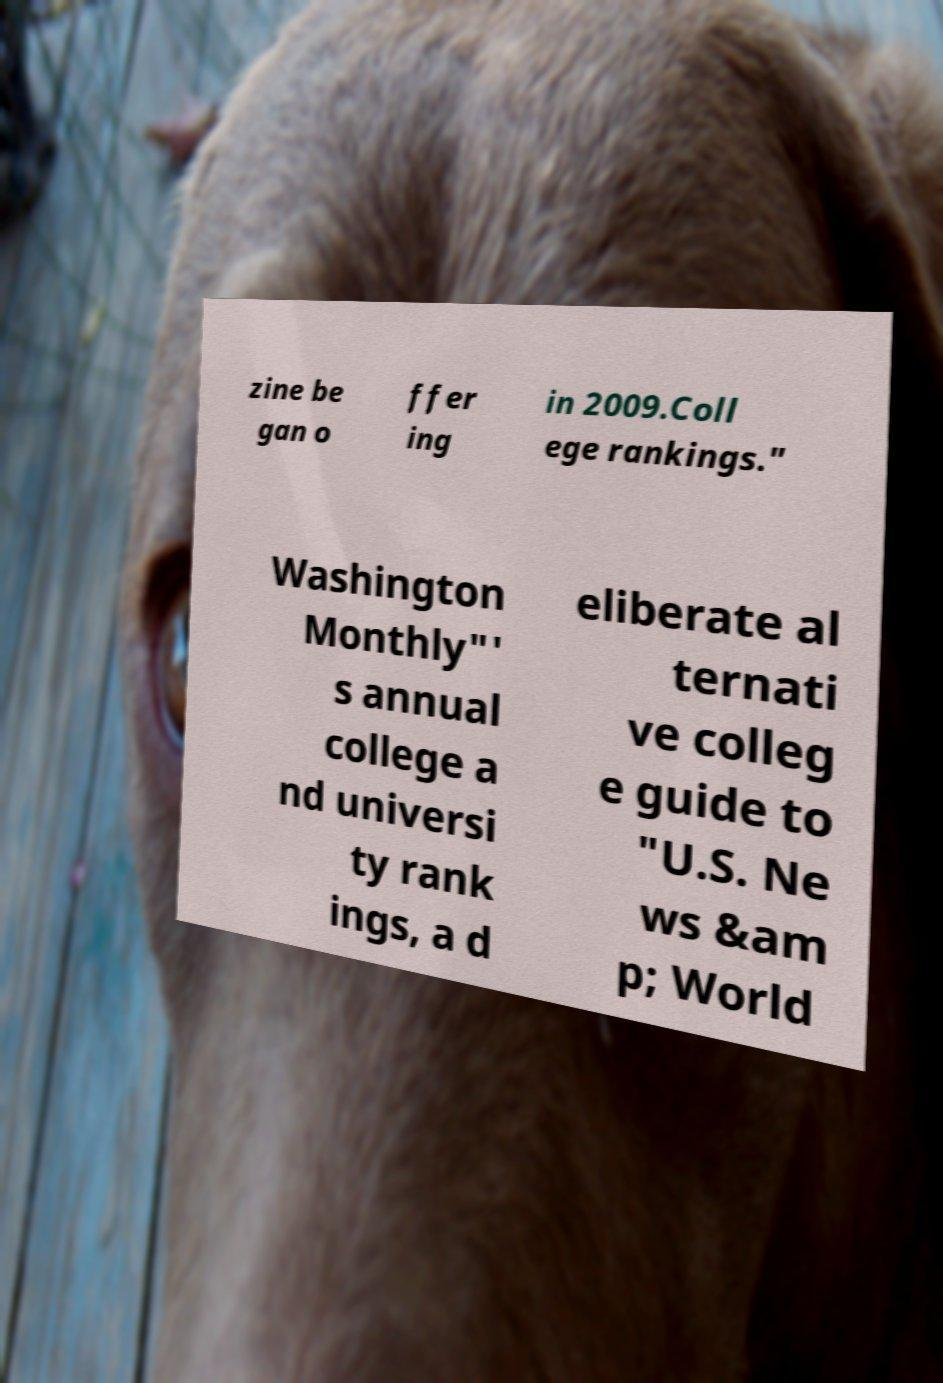Please read and relay the text visible in this image. What does it say? zine be gan o ffer ing in 2009.Coll ege rankings." Washington Monthly"' s annual college a nd universi ty rank ings, a d eliberate al ternati ve colleg e guide to "U.S. Ne ws &am p; World 